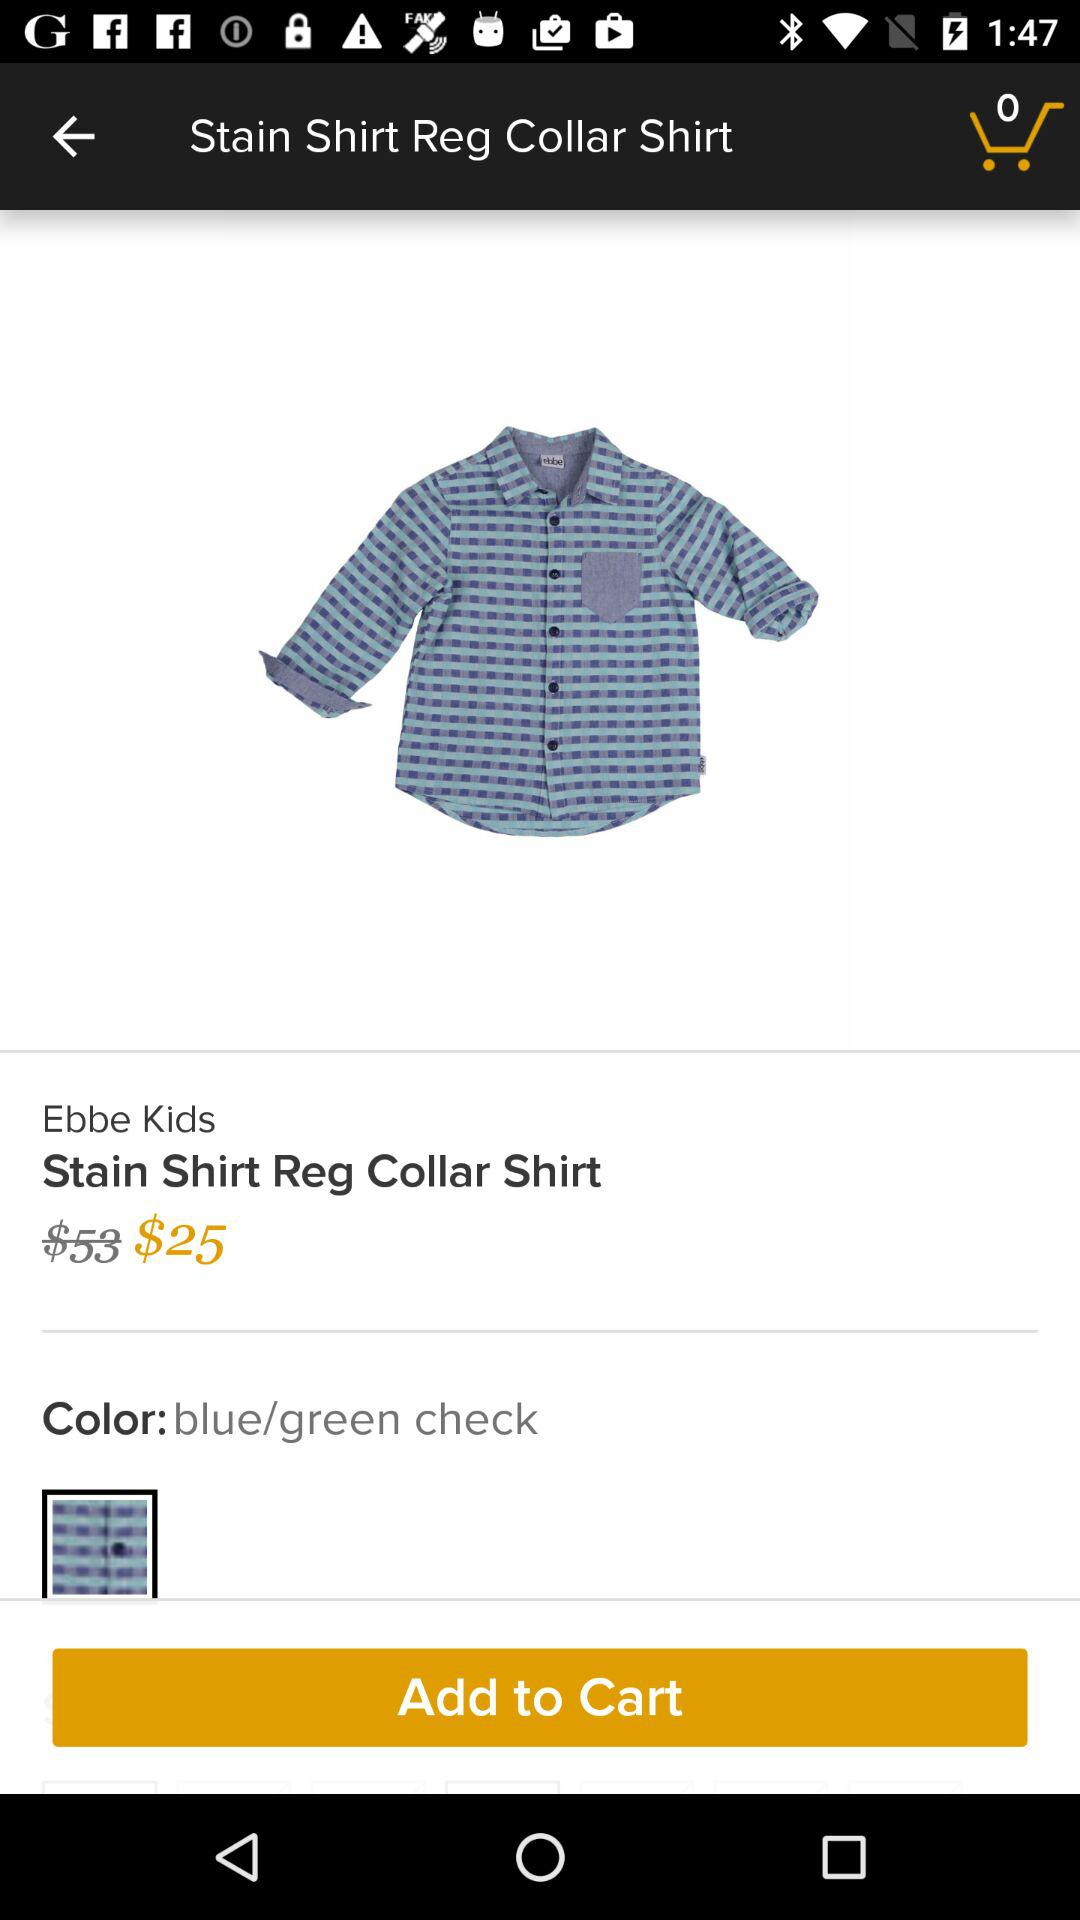What is the color of the shirt? The color of the shirt is blue or green. 